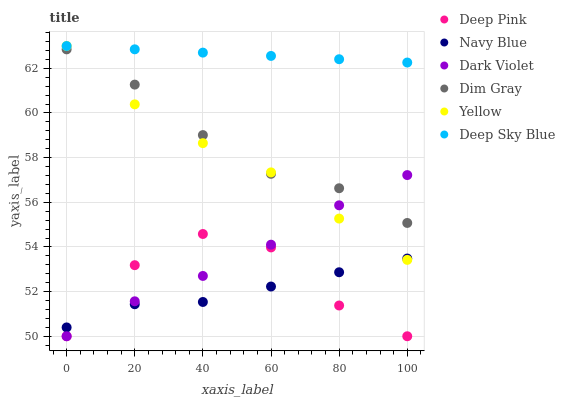Does Navy Blue have the minimum area under the curve?
Answer yes or no. Yes. Does Deep Sky Blue have the maximum area under the curve?
Answer yes or no. Yes. Does Yellow have the minimum area under the curve?
Answer yes or no. No. Does Yellow have the maximum area under the curve?
Answer yes or no. No. Is Deep Sky Blue the smoothest?
Answer yes or no. Yes. Is Deep Pink the roughest?
Answer yes or no. Yes. Is Navy Blue the smoothest?
Answer yes or no. No. Is Navy Blue the roughest?
Answer yes or no. No. Does Deep Pink have the lowest value?
Answer yes or no. Yes. Does Navy Blue have the lowest value?
Answer yes or no. No. Does Deep Sky Blue have the highest value?
Answer yes or no. Yes. Does Navy Blue have the highest value?
Answer yes or no. No. Is Dim Gray less than Deep Sky Blue?
Answer yes or no. Yes. Is Deep Sky Blue greater than Navy Blue?
Answer yes or no. Yes. Does Yellow intersect Dim Gray?
Answer yes or no. Yes. Is Yellow less than Dim Gray?
Answer yes or no. No. Is Yellow greater than Dim Gray?
Answer yes or no. No. Does Dim Gray intersect Deep Sky Blue?
Answer yes or no. No. 